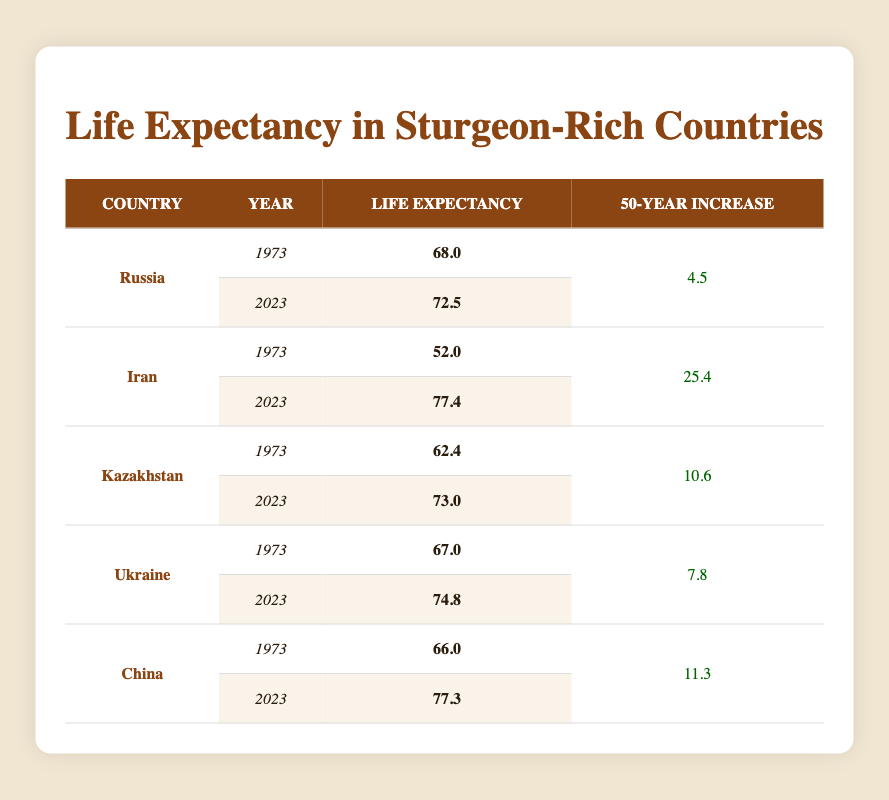What is the life expectancy in Russia in 2023? From the table, the row for Russia in 2023 shows a life expectancy of 72.5 years.
Answer: 72.5 Which country saw the largest increase in life expectancy over 50 years? By comparing the '50-Year Increase' column, Iran shows the largest increase of 25.4 years.
Answer: Iran What was the life expectancy in Kazakhstan in 1973? Referring to the table, the life expectancy in Kazakhstan in 1973 is shown as 62.4 years.
Answer: 62.4 Is the life expectancy in China greater than that in Ukraine for the year 2023? The life expectancy in China for 2023 is 77.3 years and for Ukraine is 74.8 years. Since 77.3 is greater than 74.8, the answer is yes.
Answer: Yes What is the average life expectancy in 1973 for all listed countries? Summing the life expectancies in 1973: (68.0 + 52.0 + 62.4 + 67.0 + 66.0) = 315.4. There are 5 data points, so the average is 315.4 / 5 = 63.08.
Answer: 63.08 How much has life expectancy increased in Kazakhstan over the last 50 years? The table indicates that the life expectancy in Kazakhstan increased from 62.4 in 1973 to 73.0 in 2023. The increase is calculated as 73.0 - 62.4 = 10.6 years.
Answer: 10.6 Did life expectancy in Iran exceed 77 years in 2023? The table shows that the life expectancy in Iran for 2023 is 77.4 years, which is greater than 77 years. Therefore, the answer is yes.
Answer: Yes What is the total increase in life expectancy across all the countries listed? Adding the increases: (4.5 from Russia + 25.4 from Iran + 10.6 from Kazakhstan + 7.8 from Ukraine + 11.3 from China) = 59.6 years in total.
Answer: 59.6 What was the life expectancy in Ukraine in 1973? According to the table, the life expectancy in Ukraine in 1973 was 67.0 years.
Answer: 67.0 